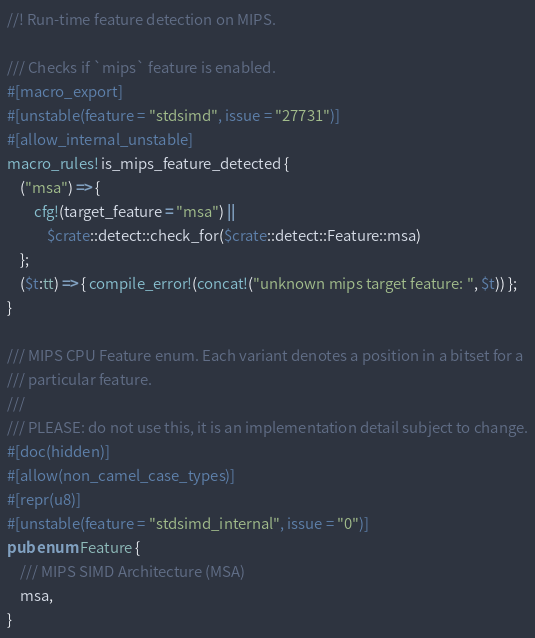Convert code to text. <code><loc_0><loc_0><loc_500><loc_500><_Rust_>//! Run-time feature detection on MIPS.

/// Checks if `mips` feature is enabled.
#[macro_export]
#[unstable(feature = "stdsimd", issue = "27731")]
#[allow_internal_unstable]
macro_rules! is_mips_feature_detected {
    ("msa") => {
        cfg!(target_feature = "msa") ||
            $crate::detect::check_for($crate::detect::Feature::msa)
    };
    ($t:tt) => { compile_error!(concat!("unknown mips target feature: ", $t)) };
}

/// MIPS CPU Feature enum. Each variant denotes a position in a bitset for a
/// particular feature.
///
/// PLEASE: do not use this, it is an implementation detail subject to change.
#[doc(hidden)]
#[allow(non_camel_case_types)]
#[repr(u8)]
#[unstable(feature = "stdsimd_internal", issue = "0")]
pub enum Feature {
    /// MIPS SIMD Architecture (MSA)
    msa,
}
</code> 